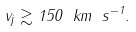<formula> <loc_0><loc_0><loc_500><loc_500>v _ { j } \gtrsim 1 5 0 \ k m \ s ^ { - 1 } .</formula> 